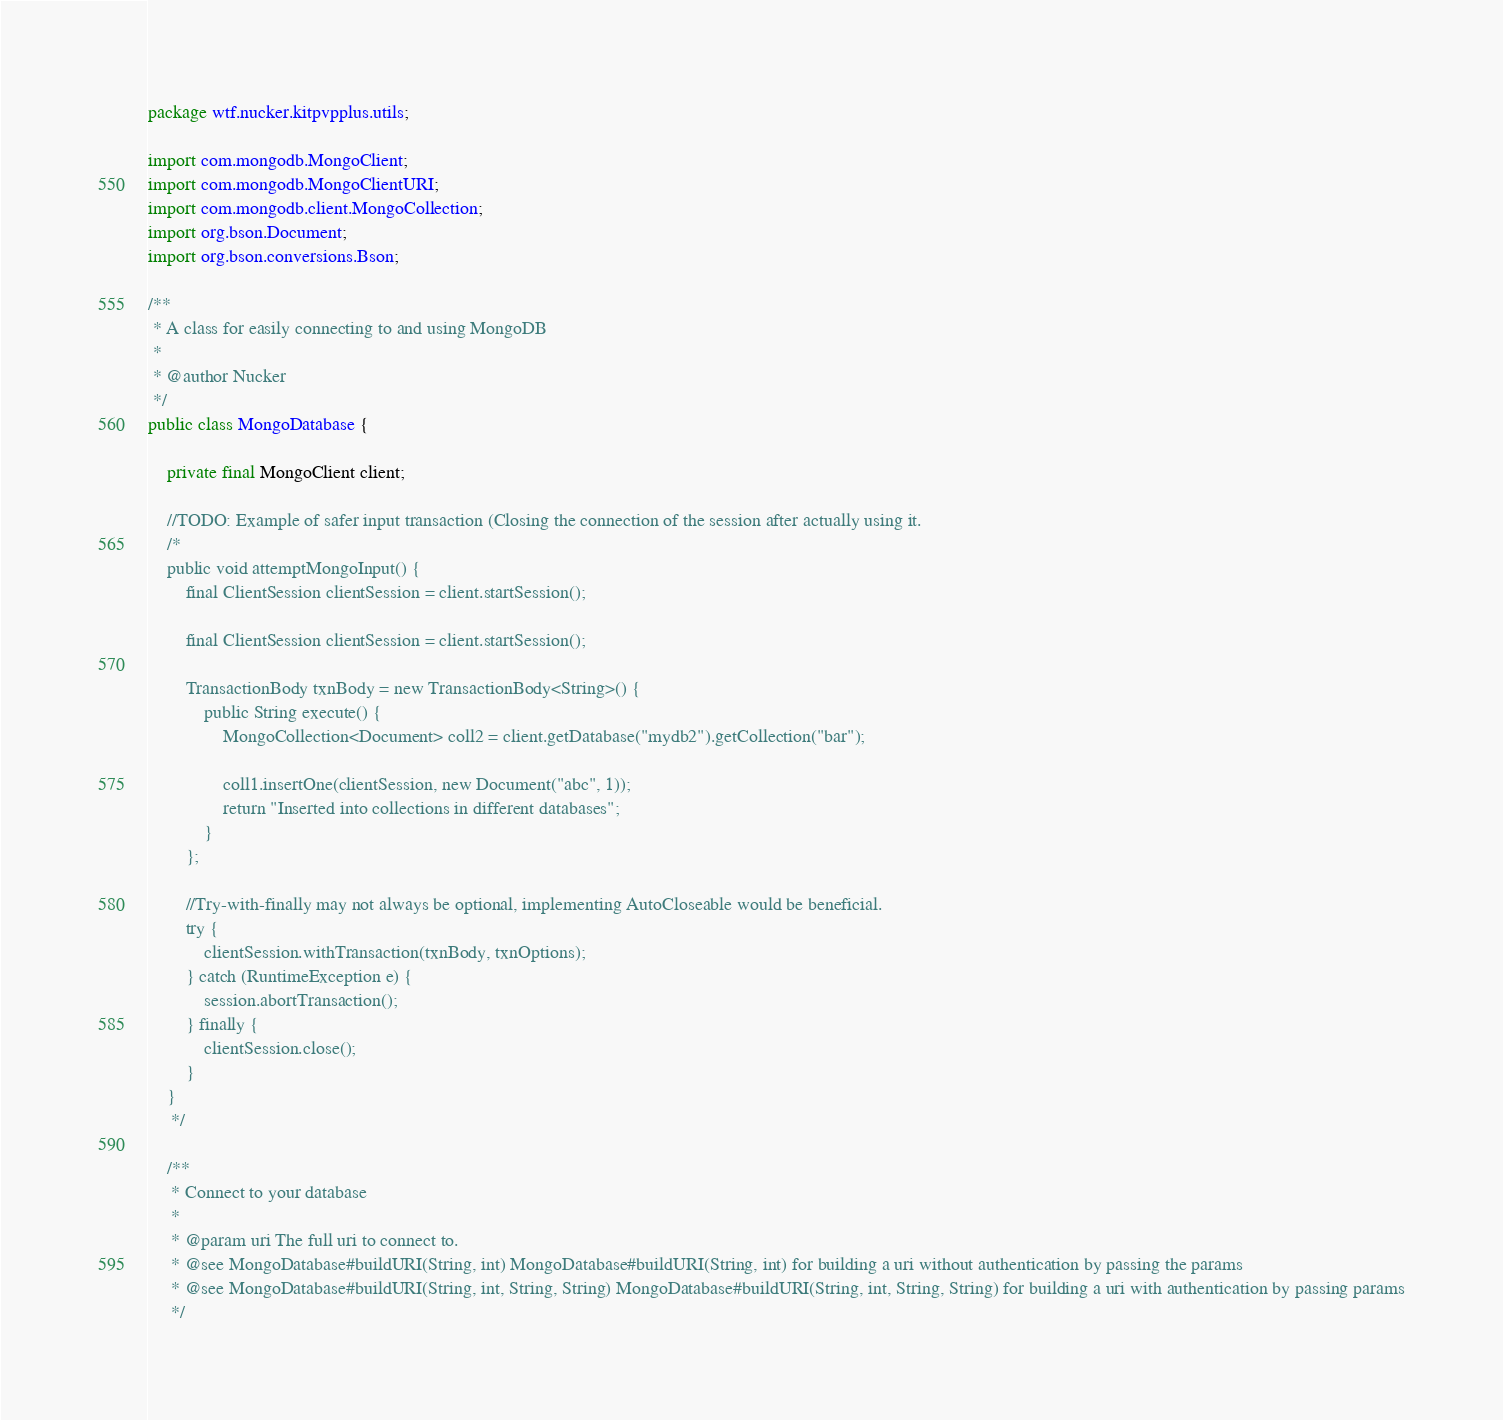<code> <loc_0><loc_0><loc_500><loc_500><_Java_>package wtf.nucker.kitpvpplus.utils;

import com.mongodb.MongoClient;
import com.mongodb.MongoClientURI;
import com.mongodb.client.MongoCollection;
import org.bson.Document;
import org.bson.conversions.Bson;

/**
 * A class for easily connecting to and using MongoDB
 *
 * @author Nucker
 */
public class MongoDatabase {

    private final MongoClient client;

    //TODO: Example of safer input transaction (Closing the connection of the session after actually using it.
    /*
    public void attemptMongoInput() {
        final ClientSession clientSession = client.startSession();

        final ClientSession clientSession = client.startSession();

        TransactionBody txnBody = new TransactionBody<String>() {
            public String execute() {
                MongoCollection<Document> coll2 = client.getDatabase("mydb2").getCollection("bar");

                coll1.insertOne(clientSession, new Document("abc", 1));
                return "Inserted into collections in different databases";
            }
        };

        //Try-with-finally may not always be optional, implementing AutoCloseable would be beneficial.
        try {
            clientSession.withTransaction(txnBody, txnOptions);
        } catch (RuntimeException e) {
            session.abortTransaction();
        } finally {
            clientSession.close();
        }
    }
     */

    /**
     * Connect to your database
     *
     * @param uri The full uri to connect to.
     * @see MongoDatabase#buildURI(String, int) MongoDatabase#buildURI(String, int) for building a uri without authentication by passing the params
     * @see MongoDatabase#buildURI(String, int, String, String) MongoDatabase#buildURI(String, int, String, String) for building a uri with authentication by passing params
     */</code> 